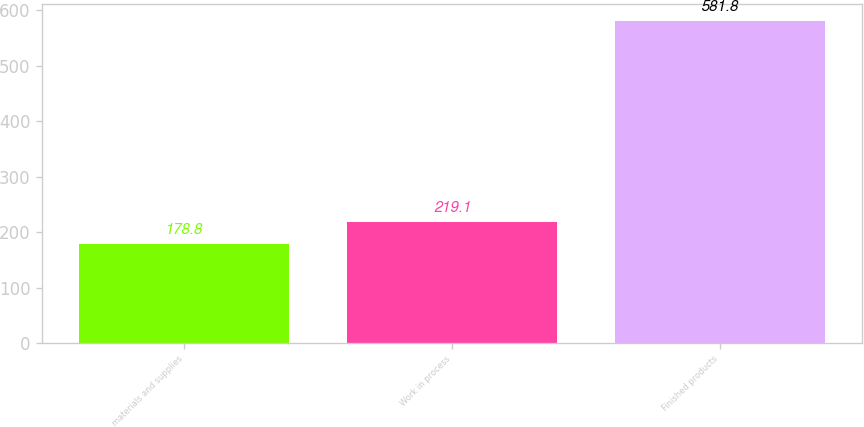<chart> <loc_0><loc_0><loc_500><loc_500><bar_chart><fcel>materials and supplies<fcel>Work in process<fcel>Finished products<nl><fcel>178.8<fcel>219.1<fcel>581.8<nl></chart> 